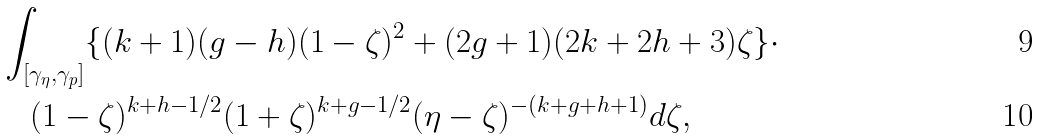Convert formula to latex. <formula><loc_0><loc_0><loc_500><loc_500>& \int _ { [ \gamma _ { \eta } , \gamma _ { p } ] } \{ ( k + 1 ) ( g - h ) ( 1 - \zeta ) ^ { 2 } + ( 2 g + 1 ) ( 2 k + 2 h + 3 ) \zeta \} \cdot \quad \\ & \quad ( 1 - \zeta ) ^ { k + h - 1 / 2 } ( 1 + \zeta ) ^ { k + g - 1 / 2 } ( \eta - \zeta ) ^ { - ( k + g + h + 1 ) } d \zeta ,</formula> 